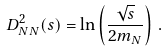<formula> <loc_0><loc_0><loc_500><loc_500>D ^ { 2 } _ { N N } ( s ) = \ln \left ( \frac { \sqrt { s } } { 2 m _ { N } } \right ) \, .</formula> 